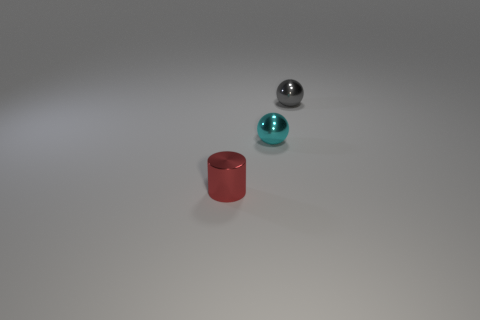What number of cyan metal balls have the same size as the metal cylinder?
Your answer should be compact. 1. Is the number of tiny gray balls that are behind the cyan shiny sphere greater than the number of cyan spheres that are right of the tiny gray shiny object?
Provide a short and direct response. Yes. The other object that is the same shape as the cyan thing is what color?
Keep it short and to the point. Gray. Is the color of the sphere that is on the left side of the tiny gray object the same as the metal cylinder?
Your answer should be compact. No. How many cylinders are there?
Keep it short and to the point. 1. Is the small cylinder that is left of the gray metal thing made of the same material as the small cyan ball?
Make the answer very short. Yes. What number of gray metal objects are behind the ball that is to the left of the gray object on the right side of the small cyan thing?
Give a very brief answer. 1. How big is the cylinder?
Provide a short and direct response. Small. There is a ball that is in front of the tiny gray ball; does it have the same color as the small metal sphere right of the tiny cyan thing?
Your response must be concise. No. What number of other things are the same shape as the tiny red metallic object?
Offer a terse response. 0. 